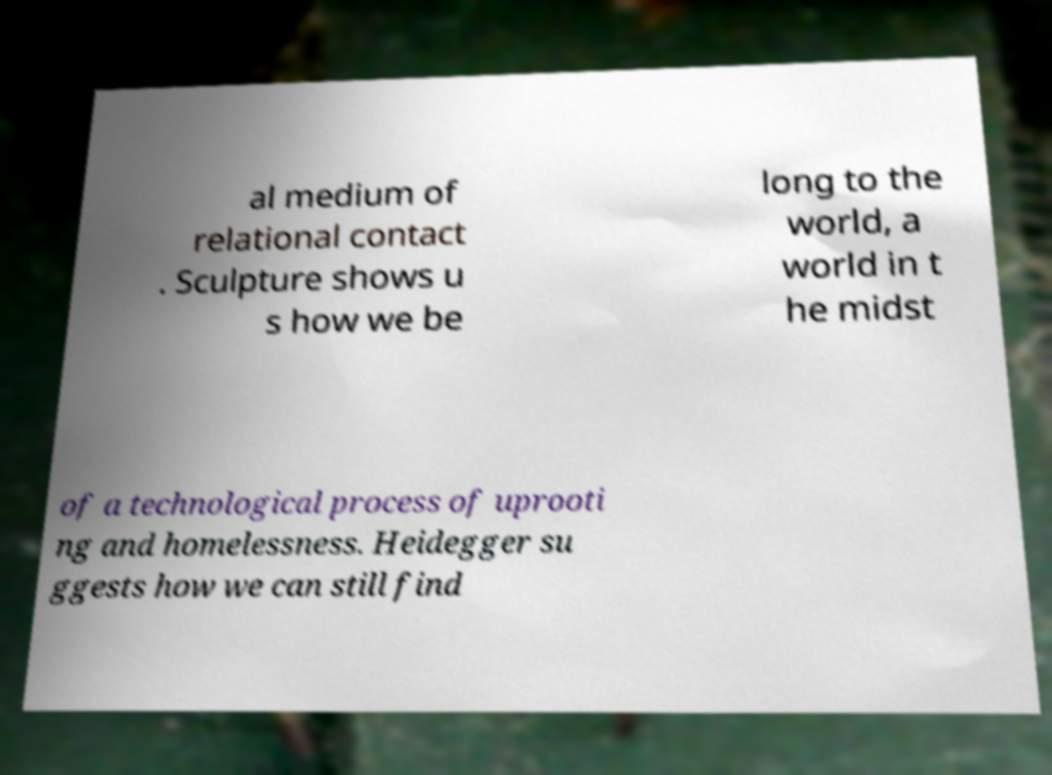There's text embedded in this image that I need extracted. Can you transcribe it verbatim? al medium of relational contact . Sculpture shows u s how we be long to the world, a world in t he midst of a technological process of uprooti ng and homelessness. Heidegger su ggests how we can still find 